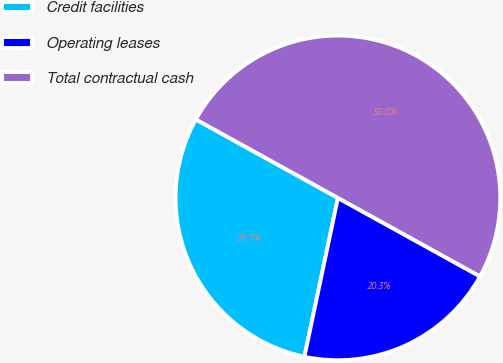<chart> <loc_0><loc_0><loc_500><loc_500><pie_chart><fcel>Credit facilities<fcel>Operating leases<fcel>Total contractual cash<nl><fcel>29.72%<fcel>20.28%<fcel>50.0%<nl></chart> 